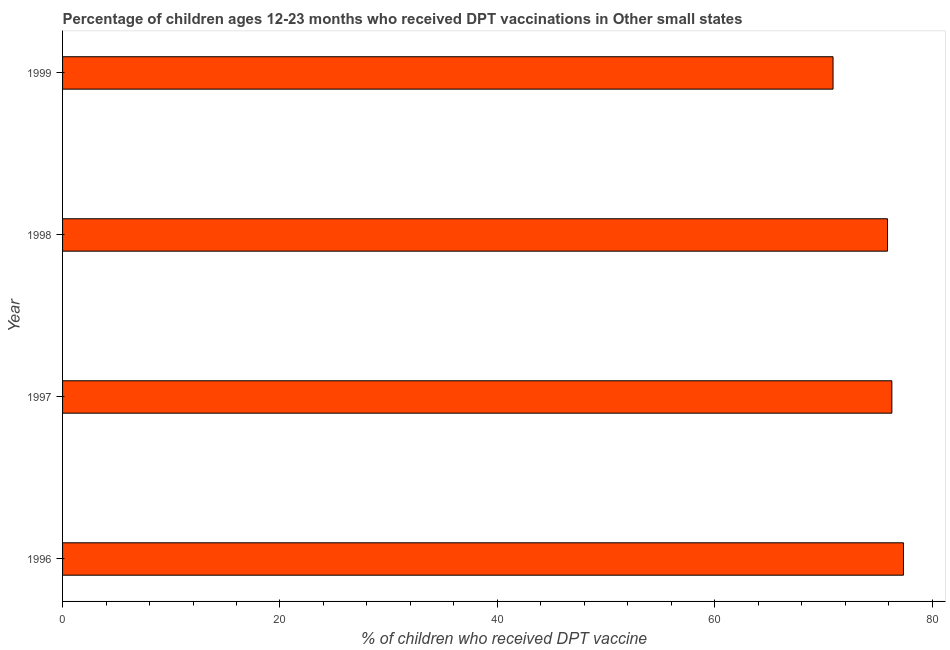Does the graph contain any zero values?
Make the answer very short. No. What is the title of the graph?
Provide a succinct answer. Percentage of children ages 12-23 months who received DPT vaccinations in Other small states. What is the label or title of the X-axis?
Ensure brevity in your answer.  % of children who received DPT vaccine. What is the label or title of the Y-axis?
Offer a terse response. Year. What is the percentage of children who received dpt vaccine in 1999?
Ensure brevity in your answer.  70.88. Across all years, what is the maximum percentage of children who received dpt vaccine?
Your response must be concise. 77.36. Across all years, what is the minimum percentage of children who received dpt vaccine?
Make the answer very short. 70.88. In which year was the percentage of children who received dpt vaccine minimum?
Ensure brevity in your answer.  1999. What is the sum of the percentage of children who received dpt vaccine?
Offer a very short reply. 300.44. What is the difference between the percentage of children who received dpt vaccine in 1996 and 1997?
Offer a terse response. 1.07. What is the average percentage of children who received dpt vaccine per year?
Give a very brief answer. 75.11. What is the median percentage of children who received dpt vaccine?
Your answer should be very brief. 76.1. In how many years, is the percentage of children who received dpt vaccine greater than 48 %?
Provide a short and direct response. 4. Is the percentage of children who received dpt vaccine in 1996 less than that in 1997?
Your answer should be very brief. No. What is the difference between the highest and the second highest percentage of children who received dpt vaccine?
Your answer should be very brief. 1.07. Is the sum of the percentage of children who received dpt vaccine in 1996 and 1999 greater than the maximum percentage of children who received dpt vaccine across all years?
Your answer should be compact. Yes. What is the difference between the highest and the lowest percentage of children who received dpt vaccine?
Offer a very short reply. 6.48. What is the difference between two consecutive major ticks on the X-axis?
Your answer should be very brief. 20. What is the % of children who received DPT vaccine in 1996?
Keep it short and to the point. 77.36. What is the % of children who received DPT vaccine of 1997?
Offer a terse response. 76.29. What is the % of children who received DPT vaccine in 1998?
Offer a very short reply. 75.9. What is the % of children who received DPT vaccine in 1999?
Ensure brevity in your answer.  70.88. What is the difference between the % of children who received DPT vaccine in 1996 and 1997?
Your answer should be very brief. 1.07. What is the difference between the % of children who received DPT vaccine in 1996 and 1998?
Your response must be concise. 1.47. What is the difference between the % of children who received DPT vaccine in 1996 and 1999?
Make the answer very short. 6.48. What is the difference between the % of children who received DPT vaccine in 1997 and 1998?
Your answer should be very brief. 0.4. What is the difference between the % of children who received DPT vaccine in 1997 and 1999?
Your answer should be compact. 5.41. What is the difference between the % of children who received DPT vaccine in 1998 and 1999?
Provide a succinct answer. 5.01. What is the ratio of the % of children who received DPT vaccine in 1996 to that in 1997?
Provide a succinct answer. 1.01. What is the ratio of the % of children who received DPT vaccine in 1996 to that in 1999?
Offer a terse response. 1.09. What is the ratio of the % of children who received DPT vaccine in 1997 to that in 1998?
Offer a terse response. 1. What is the ratio of the % of children who received DPT vaccine in 1997 to that in 1999?
Ensure brevity in your answer.  1.08. What is the ratio of the % of children who received DPT vaccine in 1998 to that in 1999?
Keep it short and to the point. 1.07. 